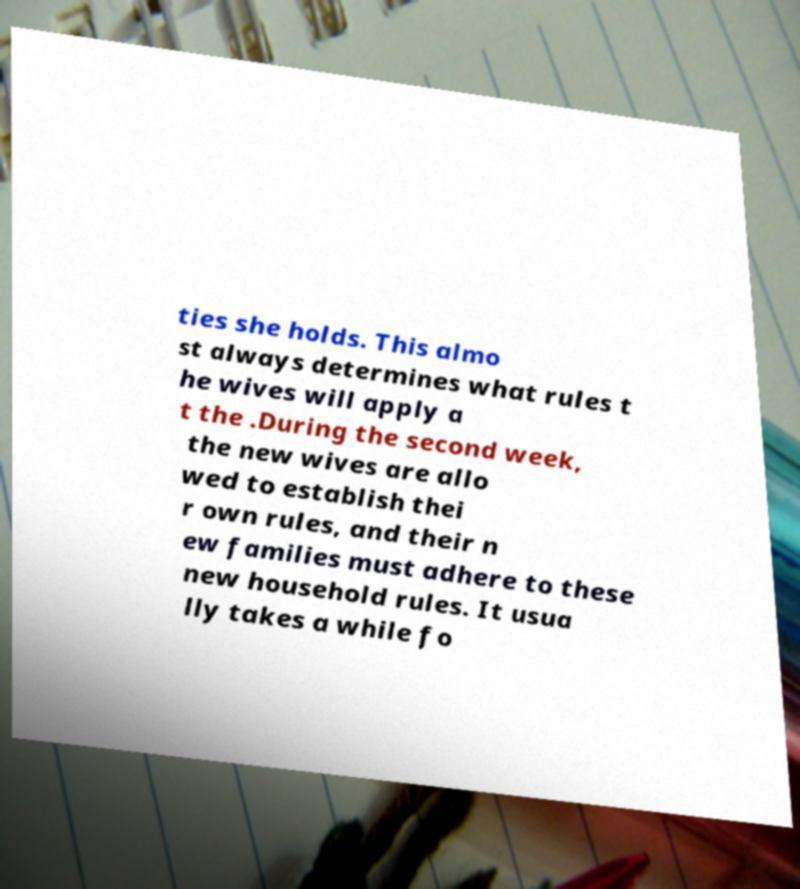There's text embedded in this image that I need extracted. Can you transcribe it verbatim? ties she holds. This almo st always determines what rules t he wives will apply a t the .During the second week, the new wives are allo wed to establish thei r own rules, and their n ew families must adhere to these new household rules. It usua lly takes a while fo 